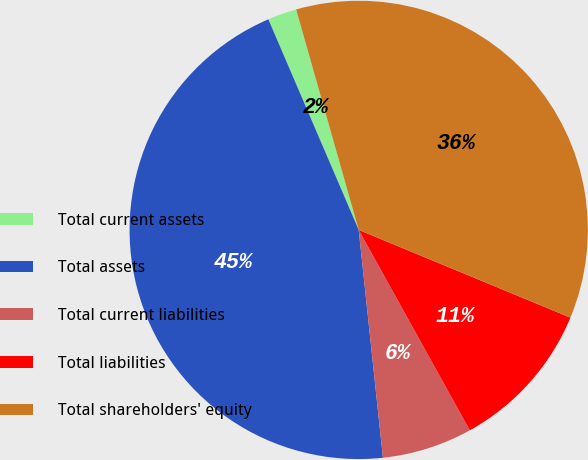<chart> <loc_0><loc_0><loc_500><loc_500><pie_chart><fcel>Total current assets<fcel>Total assets<fcel>Total current liabilities<fcel>Total liabilities<fcel>Total shareholders' equity<nl><fcel>2.05%<fcel>45.23%<fcel>6.37%<fcel>10.69%<fcel>35.65%<nl></chart> 